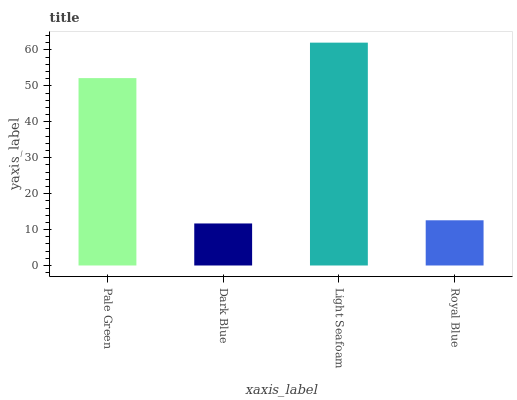Is Dark Blue the minimum?
Answer yes or no. Yes. Is Light Seafoam the maximum?
Answer yes or no. Yes. Is Light Seafoam the minimum?
Answer yes or no. No. Is Dark Blue the maximum?
Answer yes or no. No. Is Light Seafoam greater than Dark Blue?
Answer yes or no. Yes. Is Dark Blue less than Light Seafoam?
Answer yes or no. Yes. Is Dark Blue greater than Light Seafoam?
Answer yes or no. No. Is Light Seafoam less than Dark Blue?
Answer yes or no. No. Is Pale Green the high median?
Answer yes or no. Yes. Is Royal Blue the low median?
Answer yes or no. Yes. Is Light Seafoam the high median?
Answer yes or no. No. Is Light Seafoam the low median?
Answer yes or no. No. 